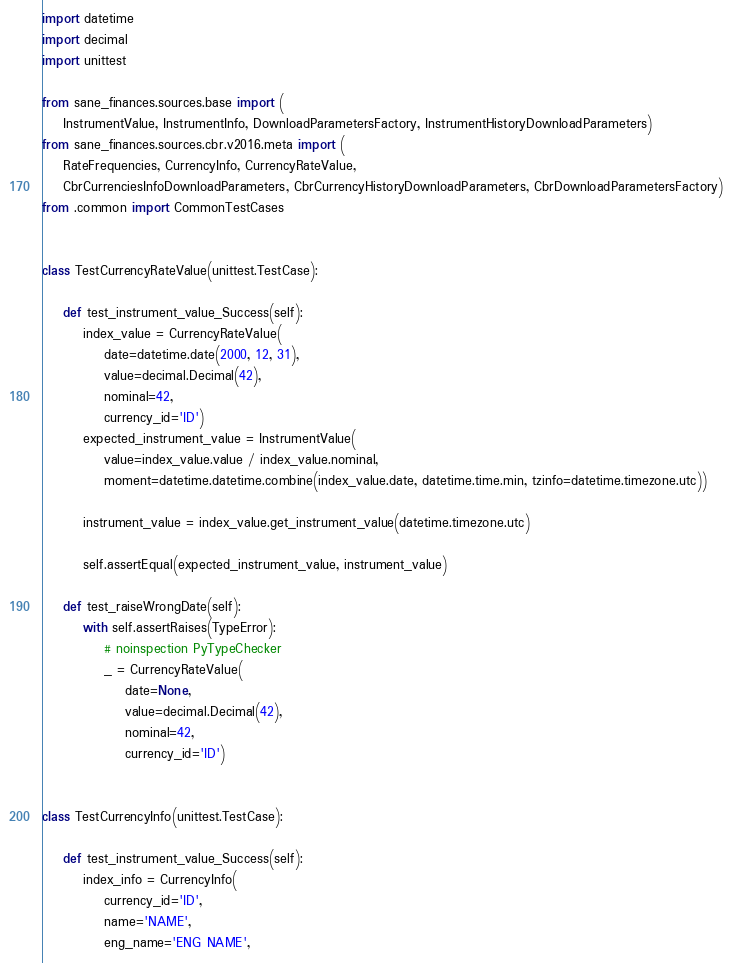Convert code to text. <code><loc_0><loc_0><loc_500><loc_500><_Python_>
import datetime
import decimal
import unittest

from sane_finances.sources.base import (
    InstrumentValue, InstrumentInfo, DownloadParametersFactory, InstrumentHistoryDownloadParameters)
from sane_finances.sources.cbr.v2016.meta import (
    RateFrequencies, CurrencyInfo, CurrencyRateValue,
    CbrCurrenciesInfoDownloadParameters, CbrCurrencyHistoryDownloadParameters, CbrDownloadParametersFactory)
from .common import CommonTestCases


class TestCurrencyRateValue(unittest.TestCase):

    def test_instrument_value_Success(self):
        index_value = CurrencyRateValue(
            date=datetime.date(2000, 12, 31),
            value=decimal.Decimal(42),
            nominal=42,
            currency_id='ID')
        expected_instrument_value = InstrumentValue(
            value=index_value.value / index_value.nominal,
            moment=datetime.datetime.combine(index_value.date, datetime.time.min, tzinfo=datetime.timezone.utc))

        instrument_value = index_value.get_instrument_value(datetime.timezone.utc)

        self.assertEqual(expected_instrument_value, instrument_value)

    def test_raiseWrongDate(self):
        with self.assertRaises(TypeError):
            # noinspection PyTypeChecker
            _ = CurrencyRateValue(
                date=None,
                value=decimal.Decimal(42),
                nominal=42,
                currency_id='ID')


class TestCurrencyInfo(unittest.TestCase):

    def test_instrument_value_Success(self):
        index_info = CurrencyInfo(
            currency_id='ID',
            name='NAME',
            eng_name='ENG NAME',</code> 